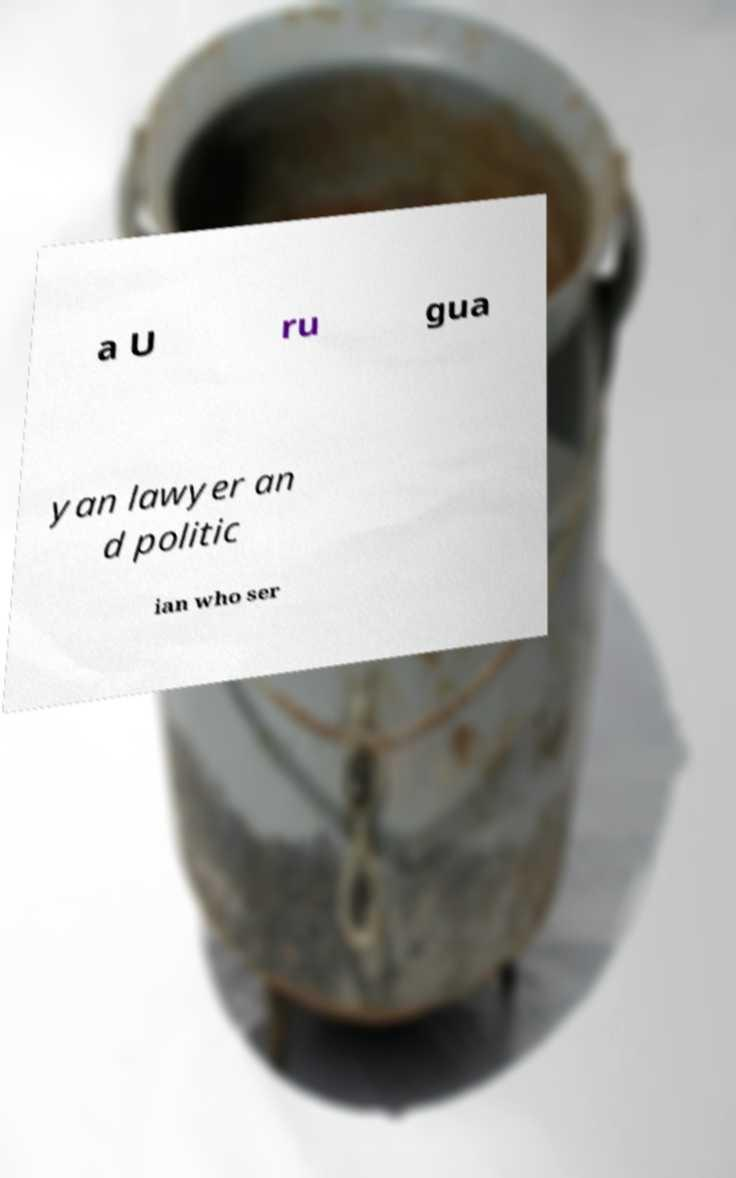Please identify and transcribe the text found in this image. a U ru gua yan lawyer an d politic ian who ser 